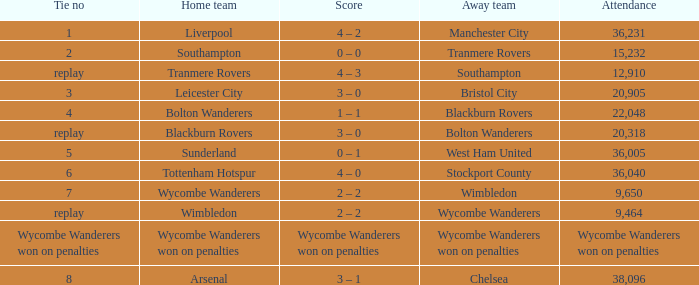Parse the full table. {'header': ['Tie no', 'Home team', 'Score', 'Away team', 'Attendance'], 'rows': [['1', 'Liverpool', '4 – 2', 'Manchester City', '36,231'], ['2', 'Southampton', '0 – 0', 'Tranmere Rovers', '15,232'], ['replay', 'Tranmere Rovers', '4 – 3', 'Southampton', '12,910'], ['3', 'Leicester City', '3 – 0', 'Bristol City', '20,905'], ['4', 'Bolton Wanderers', '1 – 1', 'Blackburn Rovers', '22,048'], ['replay', 'Blackburn Rovers', '3 – 0', 'Bolton Wanderers', '20,318'], ['5', 'Sunderland', '0 – 1', 'West Ham United', '36,005'], ['6', 'Tottenham Hotspur', '4 – 0', 'Stockport County', '36,040'], ['7', 'Wycombe Wanderers', '2 – 2', 'Wimbledon', '9,650'], ['replay', 'Wimbledon', '2 – 2', 'Wycombe Wanderers', '9,464'], ['Wycombe Wanderers won on penalties', 'Wycombe Wanderers won on penalties', 'Wycombe Wanderers won on penalties', 'Wycombe Wanderers won on penalties', 'Wycombe Wanderers won on penalties'], ['8', 'Arsenal', '3 – 1', 'Chelsea', '38,096']]} What was the score when there was a tie of one each? 4 – 2. 